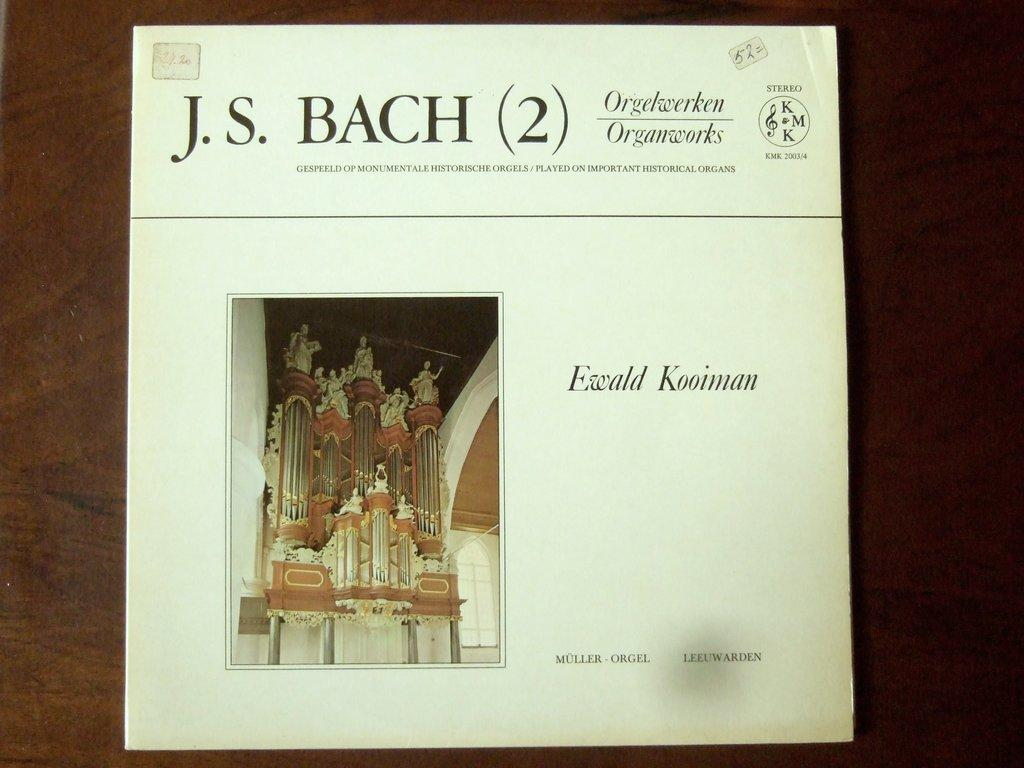<image>
Share a concise interpretation of the image provided. A record sleeve for a composition by Bach 